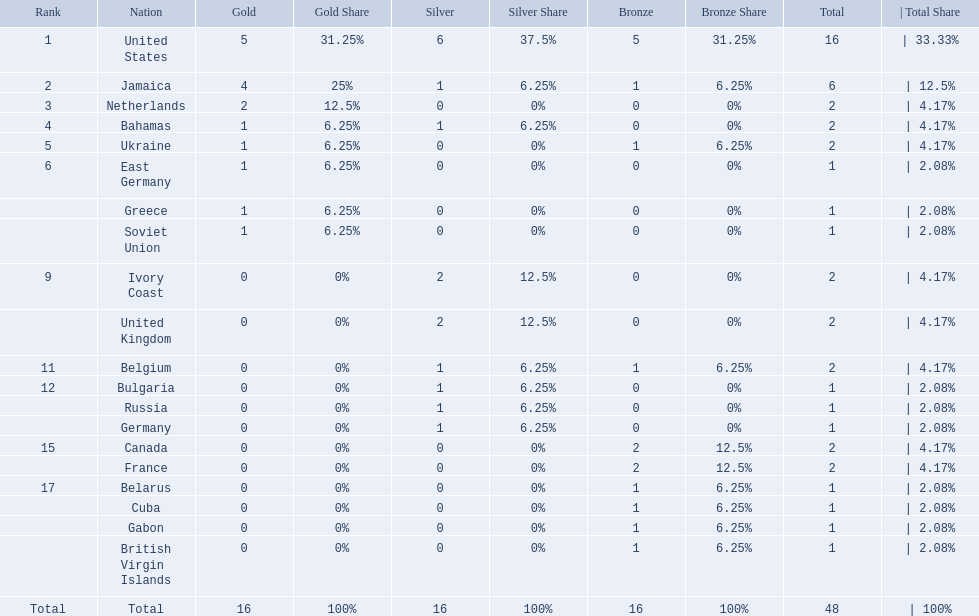What was the largest number of medals won by any country? 16. Which country won that many medals? United States. 